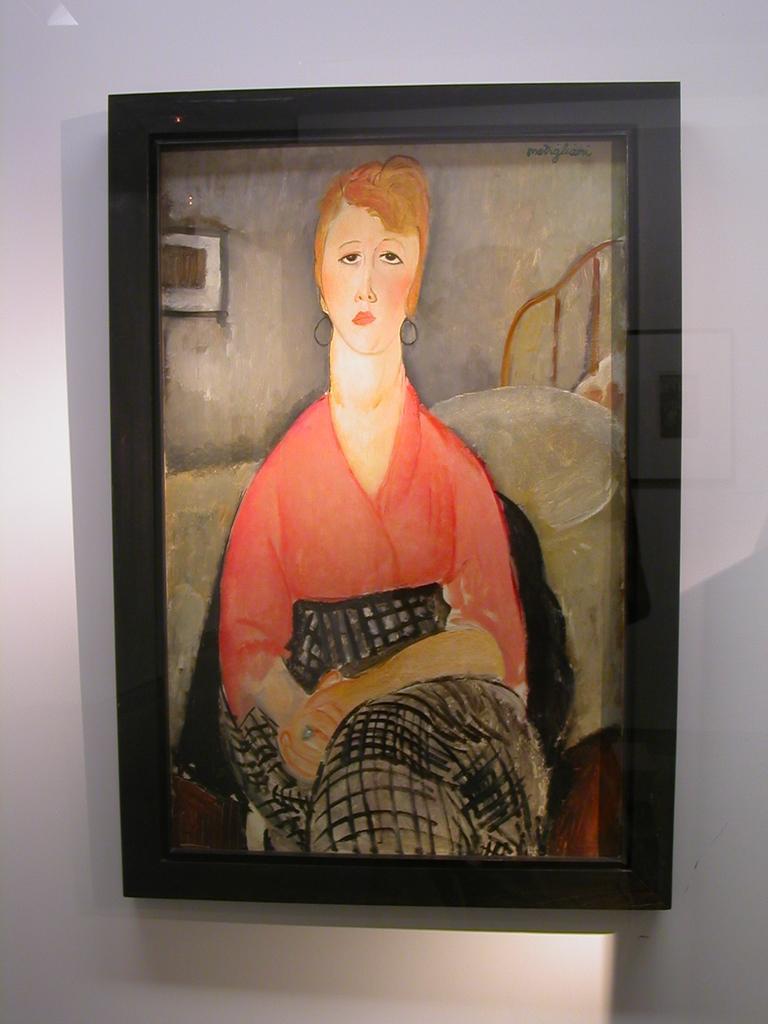Could you give a brief overview of what you see in this image? In this image we can see a photo frame on the wall. In which we can see a painting of a woman. 